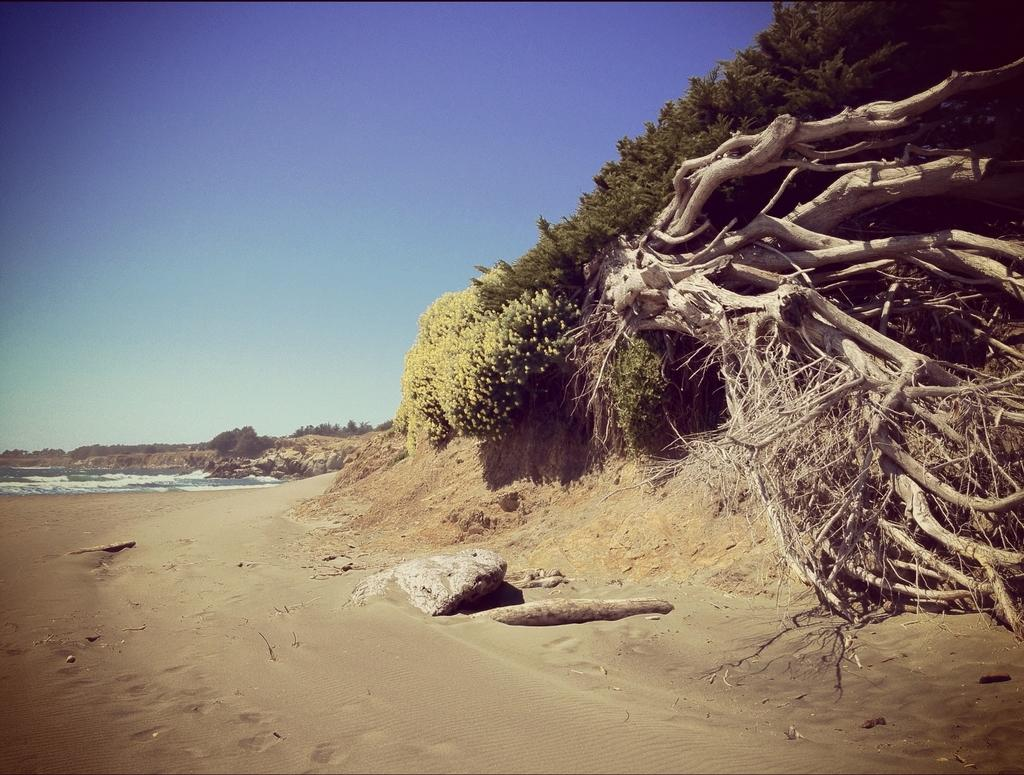What natural elements can be seen in the image? There is water and sand in the image. What can be seen in the background of the image? There are trees and the sky visible in the background of the image. What type of fruit is being picked in the image? There is no fruit or fruit-picking activity present in the image. 